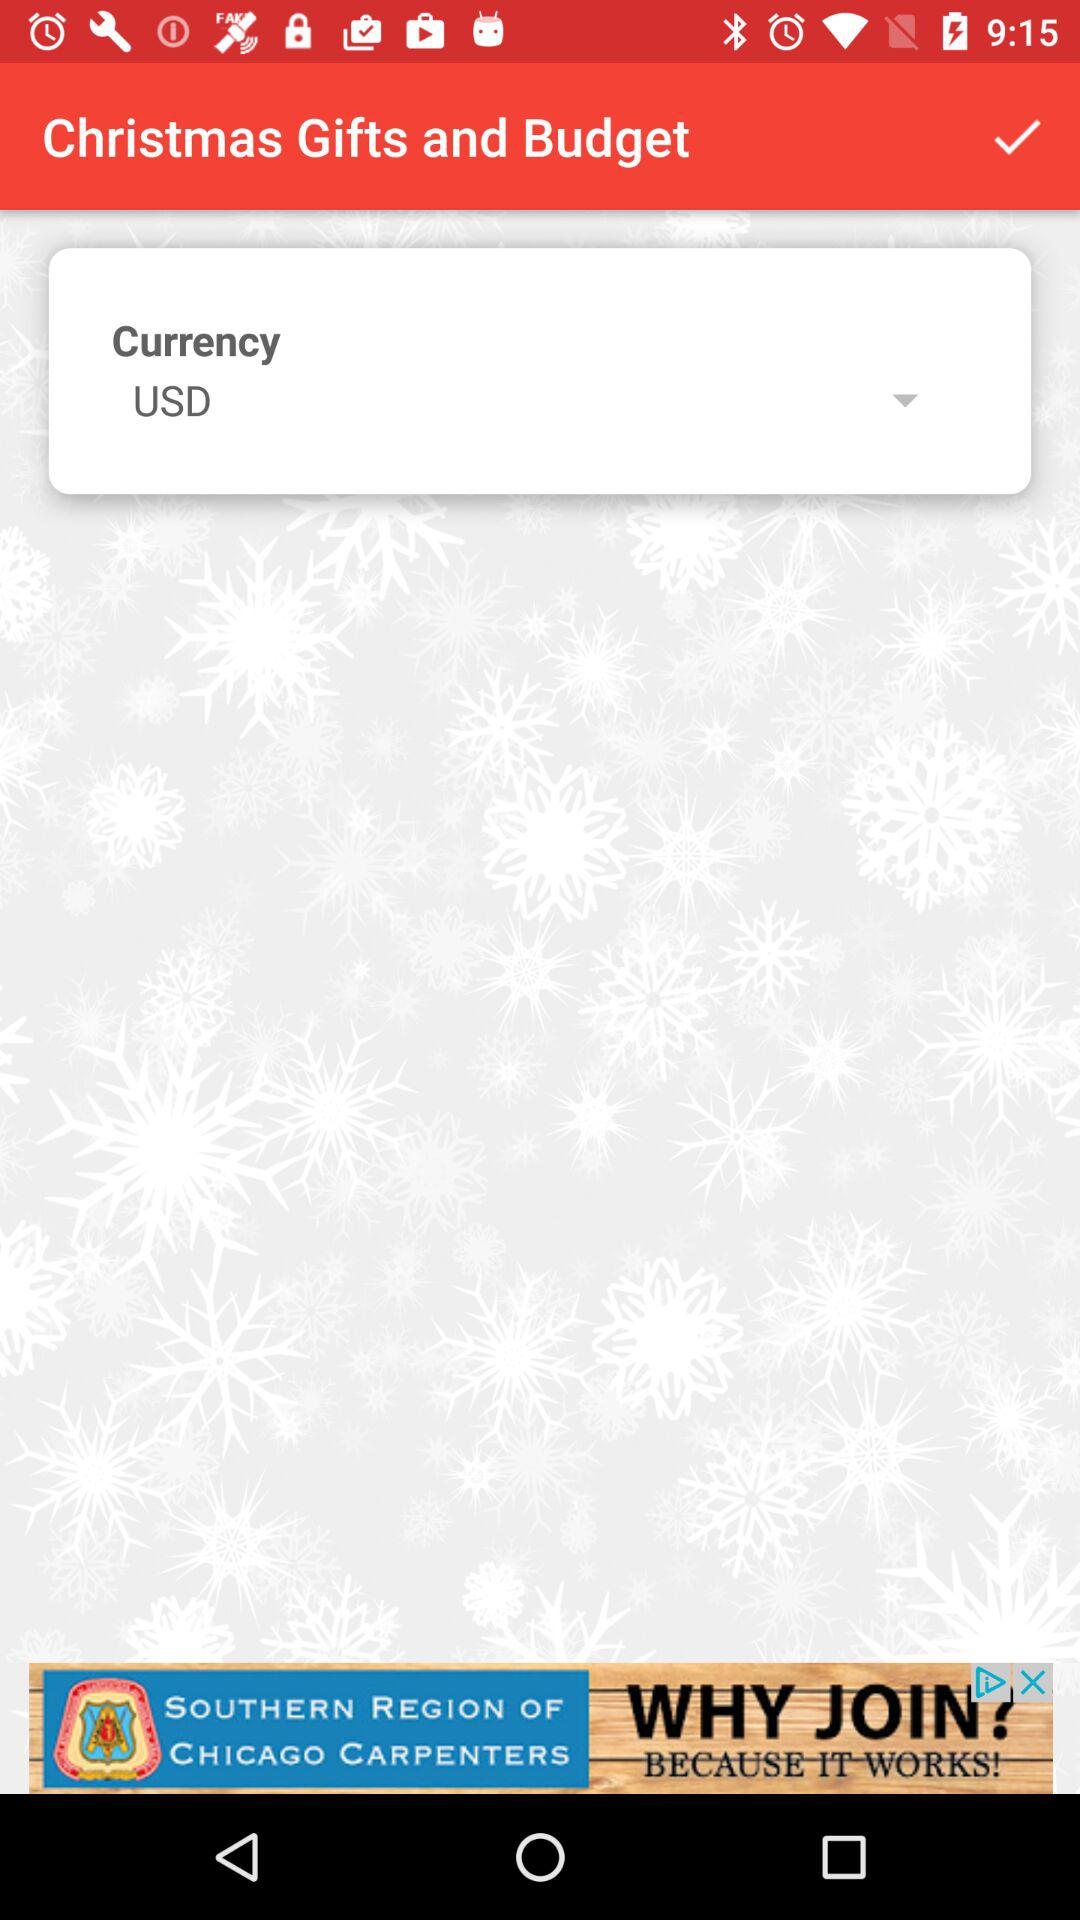What is the currency symbol for the budget?
Answer the question using a single word or phrase. USD 